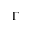Convert formula to latex. <formula><loc_0><loc_0><loc_500><loc_500>\Gamma</formula> 